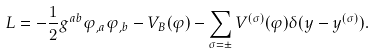Convert formula to latex. <formula><loc_0><loc_0><loc_500><loc_500>L = - \frac { 1 } { 2 } g ^ { a b } \varphi _ { , a } \varphi _ { , b } - V _ { B } ( \varphi ) - \sum _ { \sigma = \pm } V ^ { ( \sigma ) } ( \varphi ) \delta ( y - y ^ { ( \sigma ) } ) .</formula> 